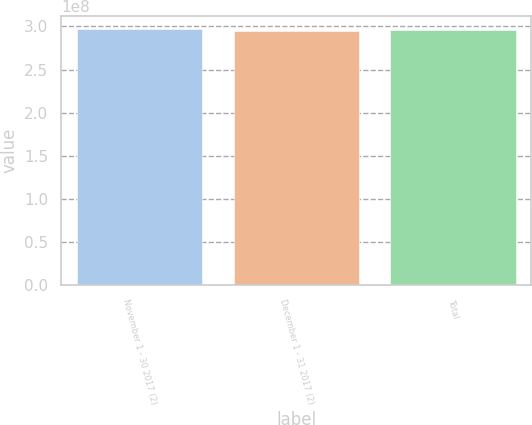Convert chart. <chart><loc_0><loc_0><loc_500><loc_500><bar_chart><fcel>November 1 - 30 2017 (2)<fcel>December 1 - 31 2017 (2)<fcel>Total<nl><fcel>2.97121e+08<fcel>2.95141e+08<fcel>2.95339e+08<nl></chart> 